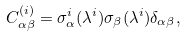Convert formula to latex. <formula><loc_0><loc_0><loc_500><loc_500>C ^ { ( i ) } _ { \alpha \beta } = \sigma ^ { i } _ { \alpha } ( \lambda ^ { i } ) \sigma _ { \beta } ( \lambda ^ { i } ) \delta _ { \alpha \beta } ,</formula> 